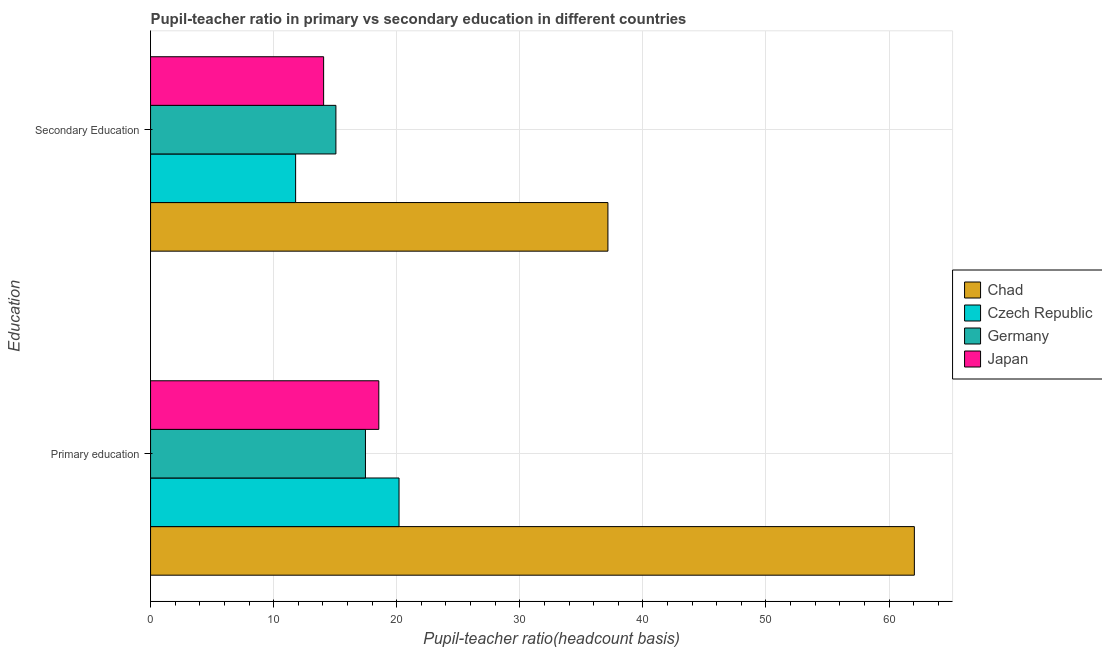How many different coloured bars are there?
Make the answer very short. 4. How many groups of bars are there?
Provide a short and direct response. 2. Are the number of bars on each tick of the Y-axis equal?
Ensure brevity in your answer.  Yes. How many bars are there on the 1st tick from the top?
Provide a succinct answer. 4. How many bars are there on the 1st tick from the bottom?
Ensure brevity in your answer.  4. What is the label of the 2nd group of bars from the top?
Keep it short and to the point. Primary education. What is the pupil teacher ratio on secondary education in Japan?
Make the answer very short. 14.06. Across all countries, what is the maximum pupil-teacher ratio in primary education?
Your answer should be very brief. 62.05. Across all countries, what is the minimum pupil-teacher ratio in primary education?
Offer a terse response. 17.46. In which country was the pupil-teacher ratio in primary education maximum?
Keep it short and to the point. Chad. In which country was the pupil teacher ratio on secondary education minimum?
Your answer should be very brief. Czech Republic. What is the total pupil teacher ratio on secondary education in the graph?
Offer a terse response. 78.06. What is the difference between the pupil-teacher ratio in primary education in Germany and that in Chad?
Your answer should be compact. -44.6. What is the difference between the pupil teacher ratio on secondary education in Chad and the pupil-teacher ratio in primary education in Germany?
Provide a succinct answer. 19.7. What is the average pupil teacher ratio on secondary education per country?
Keep it short and to the point. 19.52. What is the difference between the pupil teacher ratio on secondary education and pupil-teacher ratio in primary education in Chad?
Your answer should be very brief. -24.9. In how many countries, is the pupil teacher ratio on secondary education greater than 34 ?
Ensure brevity in your answer.  1. What is the ratio of the pupil teacher ratio on secondary education in Czech Republic to that in Germany?
Ensure brevity in your answer.  0.78. In how many countries, is the pupil teacher ratio on secondary education greater than the average pupil teacher ratio on secondary education taken over all countries?
Your answer should be very brief. 1. What does the 3rd bar from the bottom in Primary education represents?
Give a very brief answer. Germany. How many bars are there?
Provide a short and direct response. 8. What is the difference between two consecutive major ticks on the X-axis?
Your answer should be compact. 10. How are the legend labels stacked?
Offer a terse response. Vertical. What is the title of the graph?
Give a very brief answer. Pupil-teacher ratio in primary vs secondary education in different countries. Does "Barbados" appear as one of the legend labels in the graph?
Your answer should be compact. No. What is the label or title of the X-axis?
Offer a very short reply. Pupil-teacher ratio(headcount basis). What is the label or title of the Y-axis?
Provide a succinct answer. Education. What is the Pupil-teacher ratio(headcount basis) in Chad in Primary education?
Provide a succinct answer. 62.05. What is the Pupil-teacher ratio(headcount basis) of Czech Republic in Primary education?
Provide a short and direct response. 20.19. What is the Pupil-teacher ratio(headcount basis) in Germany in Primary education?
Your answer should be compact. 17.46. What is the Pupil-teacher ratio(headcount basis) in Japan in Primary education?
Provide a short and direct response. 18.54. What is the Pupil-teacher ratio(headcount basis) in Chad in Secondary Education?
Offer a very short reply. 37.16. What is the Pupil-teacher ratio(headcount basis) of Czech Republic in Secondary Education?
Give a very brief answer. 11.79. What is the Pupil-teacher ratio(headcount basis) in Germany in Secondary Education?
Offer a terse response. 15.06. What is the Pupil-teacher ratio(headcount basis) of Japan in Secondary Education?
Offer a very short reply. 14.06. Across all Education, what is the maximum Pupil-teacher ratio(headcount basis) in Chad?
Make the answer very short. 62.05. Across all Education, what is the maximum Pupil-teacher ratio(headcount basis) in Czech Republic?
Offer a very short reply. 20.19. Across all Education, what is the maximum Pupil-teacher ratio(headcount basis) in Germany?
Offer a very short reply. 17.46. Across all Education, what is the maximum Pupil-teacher ratio(headcount basis) of Japan?
Your response must be concise. 18.54. Across all Education, what is the minimum Pupil-teacher ratio(headcount basis) in Chad?
Offer a very short reply. 37.16. Across all Education, what is the minimum Pupil-teacher ratio(headcount basis) in Czech Republic?
Your answer should be compact. 11.79. Across all Education, what is the minimum Pupil-teacher ratio(headcount basis) in Germany?
Provide a succinct answer. 15.06. Across all Education, what is the minimum Pupil-teacher ratio(headcount basis) in Japan?
Offer a very short reply. 14.06. What is the total Pupil-teacher ratio(headcount basis) of Chad in the graph?
Your answer should be compact. 99.21. What is the total Pupil-teacher ratio(headcount basis) of Czech Republic in the graph?
Give a very brief answer. 31.97. What is the total Pupil-teacher ratio(headcount basis) in Germany in the graph?
Your response must be concise. 32.52. What is the total Pupil-teacher ratio(headcount basis) of Japan in the graph?
Keep it short and to the point. 32.6. What is the difference between the Pupil-teacher ratio(headcount basis) of Chad in Primary education and that in Secondary Education?
Keep it short and to the point. 24.9. What is the difference between the Pupil-teacher ratio(headcount basis) in Czech Republic in Primary education and that in Secondary Education?
Offer a terse response. 8.4. What is the difference between the Pupil-teacher ratio(headcount basis) of Germany in Primary education and that in Secondary Education?
Ensure brevity in your answer.  2.4. What is the difference between the Pupil-teacher ratio(headcount basis) in Japan in Primary education and that in Secondary Education?
Your answer should be compact. 4.48. What is the difference between the Pupil-teacher ratio(headcount basis) in Chad in Primary education and the Pupil-teacher ratio(headcount basis) in Czech Republic in Secondary Education?
Keep it short and to the point. 50.27. What is the difference between the Pupil-teacher ratio(headcount basis) of Chad in Primary education and the Pupil-teacher ratio(headcount basis) of Germany in Secondary Education?
Your answer should be compact. 47. What is the difference between the Pupil-teacher ratio(headcount basis) in Chad in Primary education and the Pupil-teacher ratio(headcount basis) in Japan in Secondary Education?
Offer a very short reply. 47.99. What is the difference between the Pupil-teacher ratio(headcount basis) of Czech Republic in Primary education and the Pupil-teacher ratio(headcount basis) of Germany in Secondary Education?
Ensure brevity in your answer.  5.13. What is the difference between the Pupil-teacher ratio(headcount basis) of Czech Republic in Primary education and the Pupil-teacher ratio(headcount basis) of Japan in Secondary Education?
Your response must be concise. 6.13. What is the difference between the Pupil-teacher ratio(headcount basis) of Germany in Primary education and the Pupil-teacher ratio(headcount basis) of Japan in Secondary Education?
Provide a short and direct response. 3.4. What is the average Pupil-teacher ratio(headcount basis) in Chad per Education?
Make the answer very short. 49.61. What is the average Pupil-teacher ratio(headcount basis) in Czech Republic per Education?
Your answer should be compact. 15.99. What is the average Pupil-teacher ratio(headcount basis) in Germany per Education?
Your answer should be very brief. 16.26. What is the average Pupil-teacher ratio(headcount basis) of Japan per Education?
Keep it short and to the point. 16.3. What is the difference between the Pupil-teacher ratio(headcount basis) in Chad and Pupil-teacher ratio(headcount basis) in Czech Republic in Primary education?
Ensure brevity in your answer.  41.87. What is the difference between the Pupil-teacher ratio(headcount basis) of Chad and Pupil-teacher ratio(headcount basis) of Germany in Primary education?
Provide a succinct answer. 44.6. What is the difference between the Pupil-teacher ratio(headcount basis) in Chad and Pupil-teacher ratio(headcount basis) in Japan in Primary education?
Make the answer very short. 43.51. What is the difference between the Pupil-teacher ratio(headcount basis) of Czech Republic and Pupil-teacher ratio(headcount basis) of Germany in Primary education?
Ensure brevity in your answer.  2.73. What is the difference between the Pupil-teacher ratio(headcount basis) of Czech Republic and Pupil-teacher ratio(headcount basis) of Japan in Primary education?
Give a very brief answer. 1.64. What is the difference between the Pupil-teacher ratio(headcount basis) of Germany and Pupil-teacher ratio(headcount basis) of Japan in Primary education?
Your response must be concise. -1.08. What is the difference between the Pupil-teacher ratio(headcount basis) of Chad and Pupil-teacher ratio(headcount basis) of Czech Republic in Secondary Education?
Your response must be concise. 25.37. What is the difference between the Pupil-teacher ratio(headcount basis) in Chad and Pupil-teacher ratio(headcount basis) in Germany in Secondary Education?
Your response must be concise. 22.1. What is the difference between the Pupil-teacher ratio(headcount basis) in Chad and Pupil-teacher ratio(headcount basis) in Japan in Secondary Education?
Give a very brief answer. 23.1. What is the difference between the Pupil-teacher ratio(headcount basis) of Czech Republic and Pupil-teacher ratio(headcount basis) of Germany in Secondary Education?
Provide a succinct answer. -3.27. What is the difference between the Pupil-teacher ratio(headcount basis) in Czech Republic and Pupil-teacher ratio(headcount basis) in Japan in Secondary Education?
Provide a succinct answer. -2.28. What is the difference between the Pupil-teacher ratio(headcount basis) of Germany and Pupil-teacher ratio(headcount basis) of Japan in Secondary Education?
Ensure brevity in your answer.  1. What is the ratio of the Pupil-teacher ratio(headcount basis) in Chad in Primary education to that in Secondary Education?
Your answer should be very brief. 1.67. What is the ratio of the Pupil-teacher ratio(headcount basis) in Czech Republic in Primary education to that in Secondary Education?
Make the answer very short. 1.71. What is the ratio of the Pupil-teacher ratio(headcount basis) of Germany in Primary education to that in Secondary Education?
Provide a short and direct response. 1.16. What is the ratio of the Pupil-teacher ratio(headcount basis) of Japan in Primary education to that in Secondary Education?
Keep it short and to the point. 1.32. What is the difference between the highest and the second highest Pupil-teacher ratio(headcount basis) of Chad?
Make the answer very short. 24.9. What is the difference between the highest and the second highest Pupil-teacher ratio(headcount basis) of Czech Republic?
Provide a short and direct response. 8.4. What is the difference between the highest and the second highest Pupil-teacher ratio(headcount basis) of Germany?
Provide a succinct answer. 2.4. What is the difference between the highest and the second highest Pupil-teacher ratio(headcount basis) in Japan?
Keep it short and to the point. 4.48. What is the difference between the highest and the lowest Pupil-teacher ratio(headcount basis) in Chad?
Keep it short and to the point. 24.9. What is the difference between the highest and the lowest Pupil-teacher ratio(headcount basis) of Czech Republic?
Offer a terse response. 8.4. What is the difference between the highest and the lowest Pupil-teacher ratio(headcount basis) of Germany?
Give a very brief answer. 2.4. What is the difference between the highest and the lowest Pupil-teacher ratio(headcount basis) of Japan?
Give a very brief answer. 4.48. 